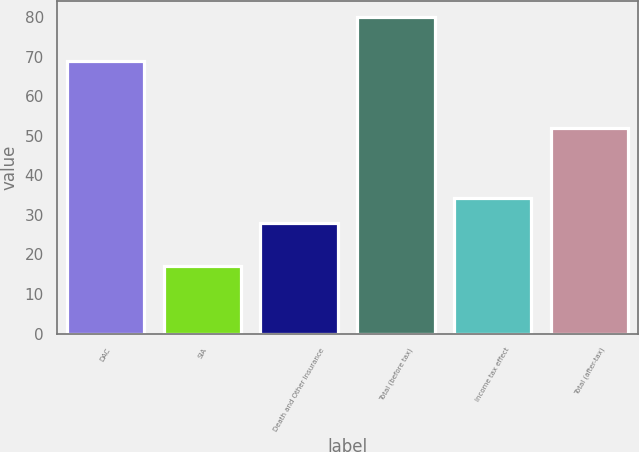Convert chart. <chart><loc_0><loc_0><loc_500><loc_500><bar_chart><fcel>DAC<fcel>SIA<fcel>Death and Other Insurance<fcel>Total (before tax)<fcel>Income tax effect<fcel>Total (after-tax)<nl><fcel>69<fcel>17<fcel>28<fcel>80<fcel>34.3<fcel>52<nl></chart> 